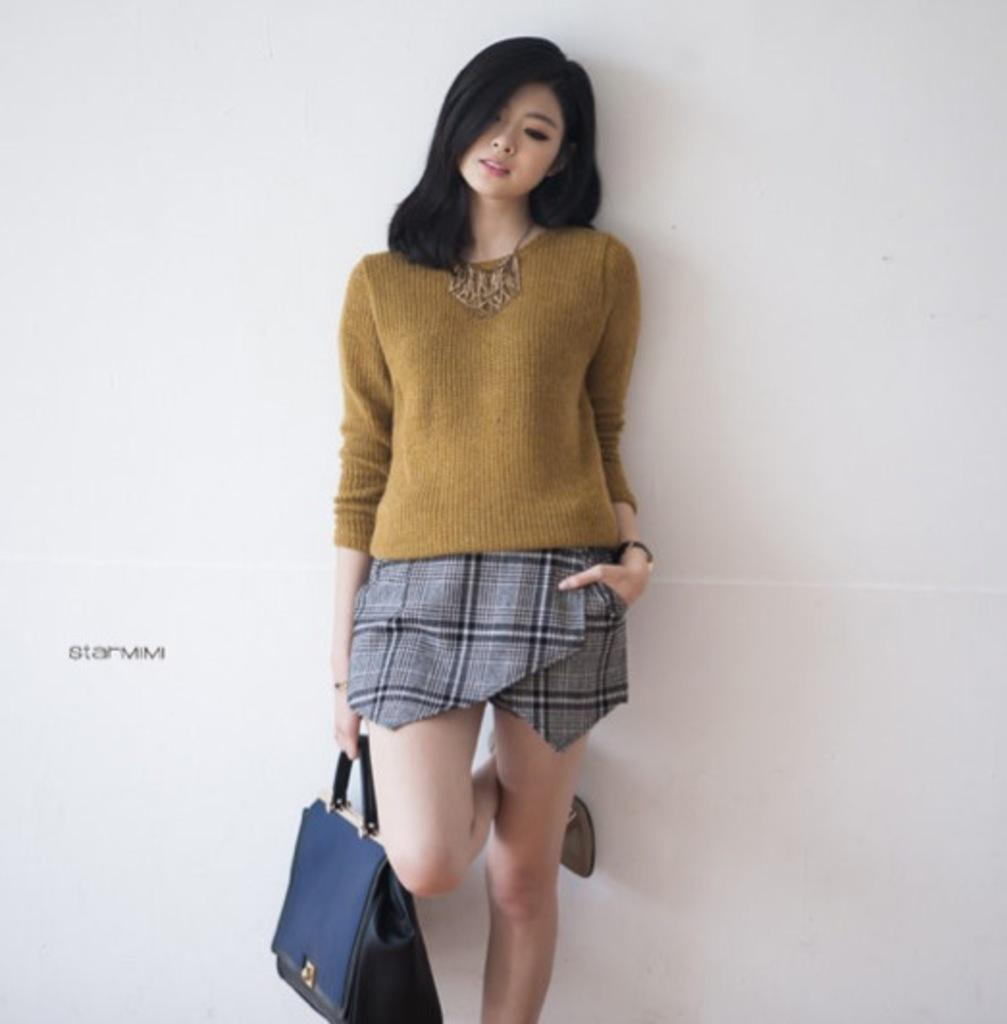Who is the main subject in the image? There is a woman in the image. What is the woman wearing? The woman is wearing a golden t-shirt. What is the woman holding in the image? The woman is holding a bag. How many fingers can be seen on the woman's left hand in the image? There is no information provided about the woman's fingers, so it cannot be determined from the image. 